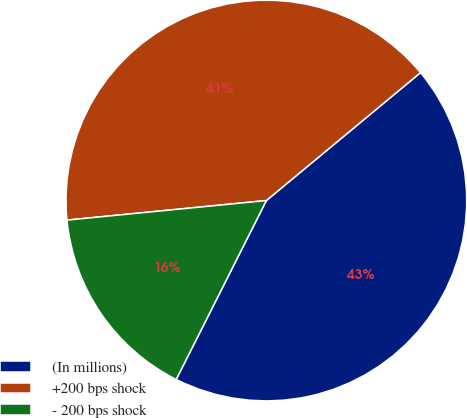Convert chart to OTSL. <chart><loc_0><loc_0><loc_500><loc_500><pie_chart><fcel>(In millions)<fcel>+200 bps shock<fcel>- 200 bps shock<nl><fcel>43.45%<fcel>40.53%<fcel>16.01%<nl></chart> 